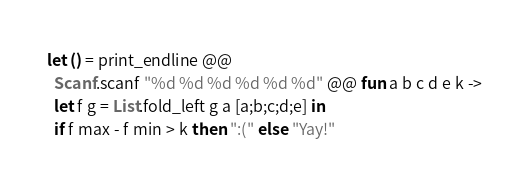Convert code to text. <code><loc_0><loc_0><loc_500><loc_500><_OCaml_>let () = print_endline @@
  Scanf.scanf "%d %d %d %d %d %d" @@ fun a b c d e k ->
  let f g = List.fold_left g a [a;b;c;d;e] in
  if f max - f min > k then ":(" else "Yay!"
</code> 